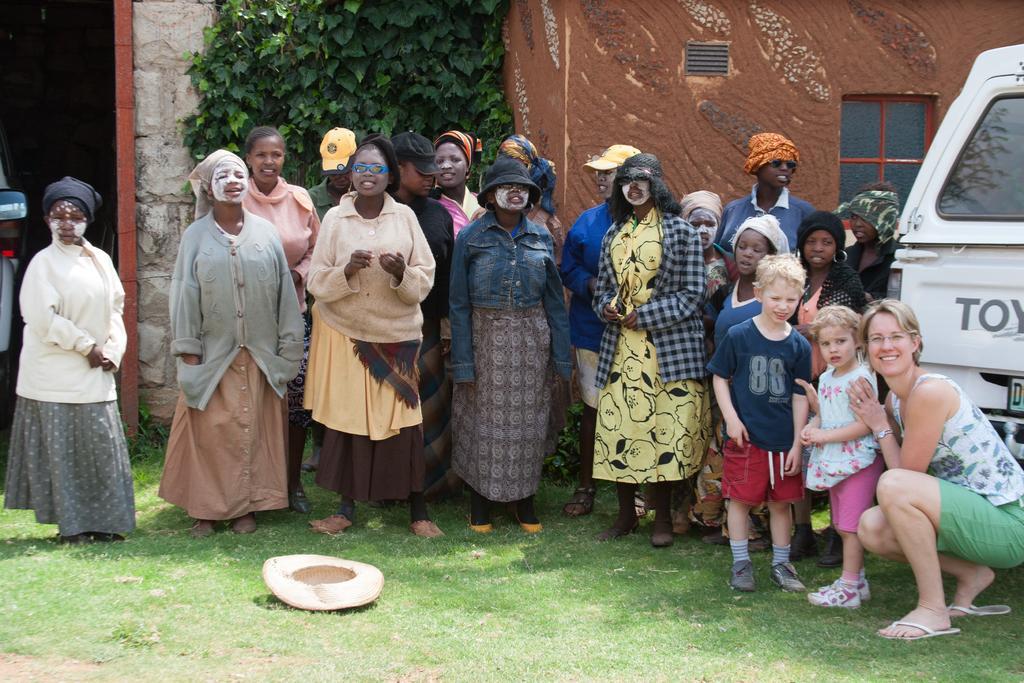Please provide a concise description of this image. This image is taken outdoors. At the bottom of the image there is a ground with grass on it. In the background there is a house with walls, a door and a window. There is a creeper with green leaves. On the left and right sides of the image two cars are parked on the ground. In the middle of the image a few people are standing on the ground and there is a hat on the ground. On the right side of the image a woman is in a squatting position and two kids are standing on the ground. 